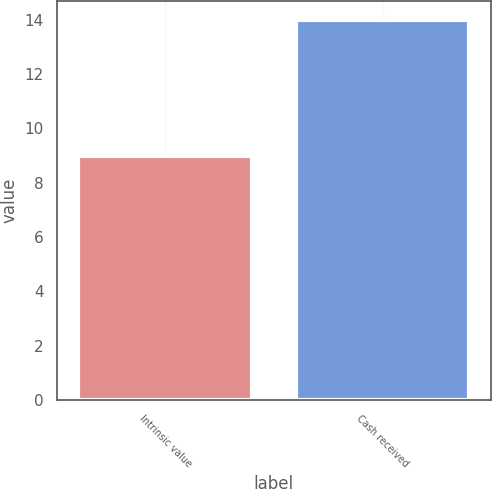Convert chart. <chart><loc_0><loc_0><loc_500><loc_500><bar_chart><fcel>Intrinsic value<fcel>Cash received<nl><fcel>9<fcel>14<nl></chart> 